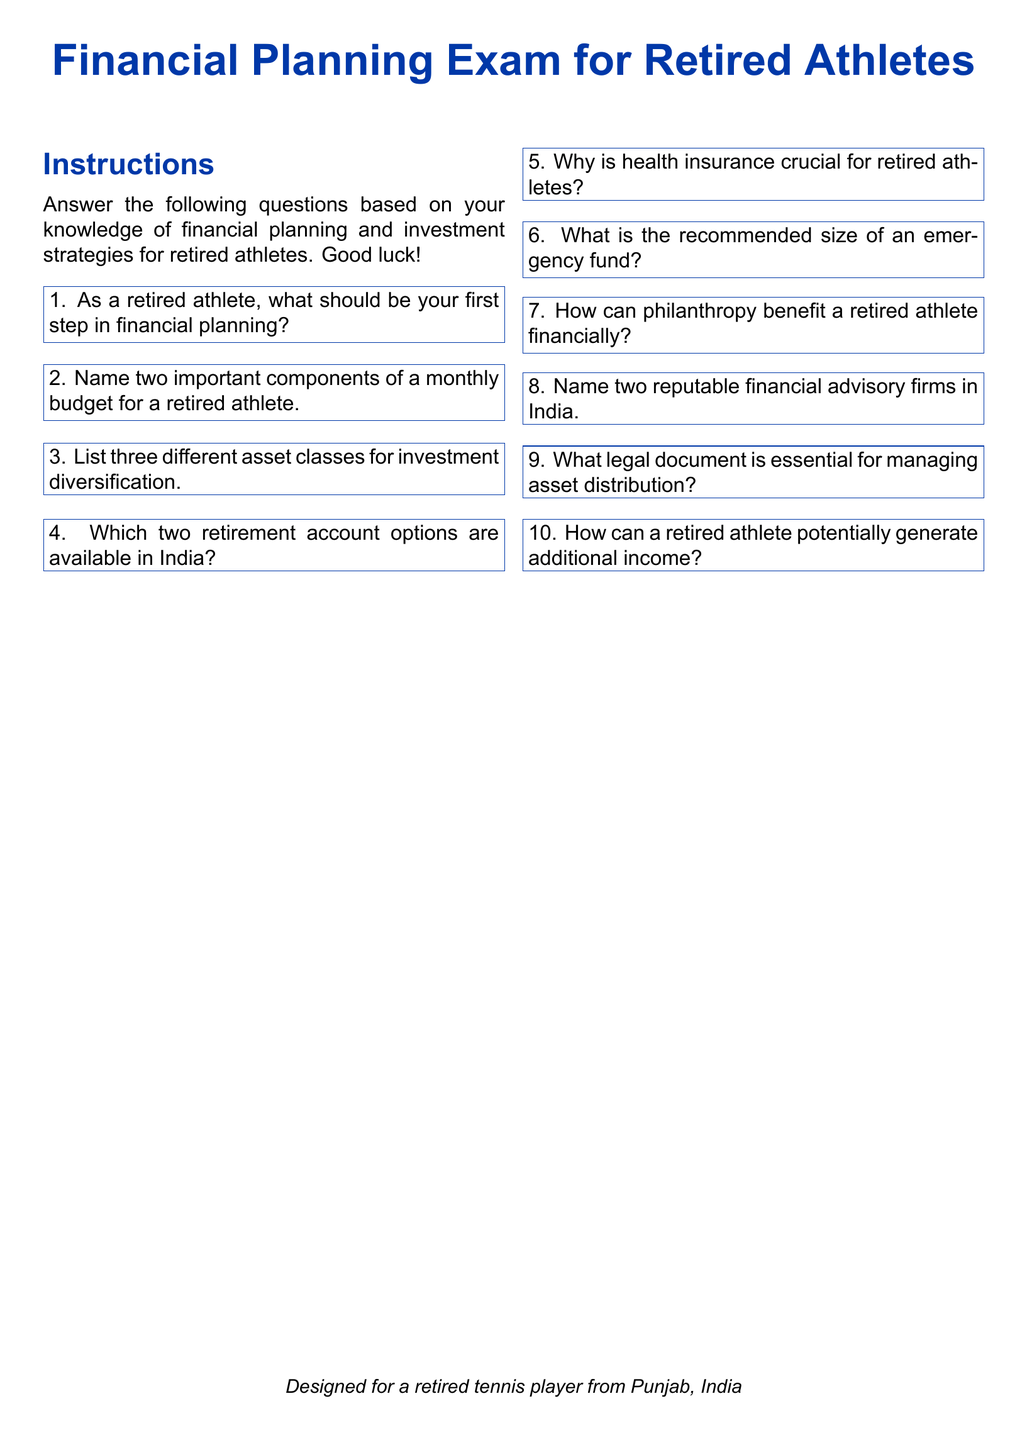What should be your first step in financial planning? This question directly asks for the first action that a retired athlete should take according to the exam instructions.
Answer: First step in financial planning Name two components of a monthly budget for a retired athlete. This question requires retrieving two specific budget components mentioned in the document, reflecting essential financial management.
Answer: Two components of a monthly budget List three different asset classes for investment diversification. This question requests three examples of asset classes that are part of investment strategies mentioned in the document.
Answer: Three different asset classes Which two retirement account options are available in India? This question asks for specific account types for retirement in India as stated in the document.
Answer: Two retirement account options Why is health insurance crucial for retired athletes? This question seeks to understand the importance of health insurance, which is a critical aspect highlighted in the document.
Answer: Health insurance cruciality What is the recommended size of an emergency fund? This question retrieves a specific financial guideline regarding emergency funds noted in the document.
Answer: Recommended size of an emergency fund How can philanthropy benefit a retired athlete financially? This question explores the financial advantages of philanthropy as discussed in the context of retired athletes.
Answer: Philanthropy benefits Name two reputable financial advisory firms in India. This question is focused on identifying specific firms mentioned in the document that provide financial advice.
Answer: Two reputable financial advisory firms What legal document is essential for managing asset distribution? This question seeks to find out which legal documentation is critical for asset management as per the document.
Answer: Essential legal document How can a retired athlete potentially generate additional income? This question asks for methods of income generation that are relevant to the retired athlete's context discussed in the document.
Answer: Generate additional income 